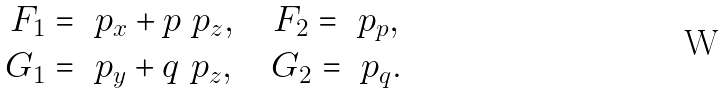<formula> <loc_0><loc_0><loc_500><loc_500>F _ { 1 } & = \ p _ { x } + p \ p _ { z } , \quad F _ { 2 } = \ p _ { p } , \\ G _ { 1 } & = \ p _ { y } + q \ p _ { z } , \quad G _ { 2 } = \ p _ { q } .</formula> 